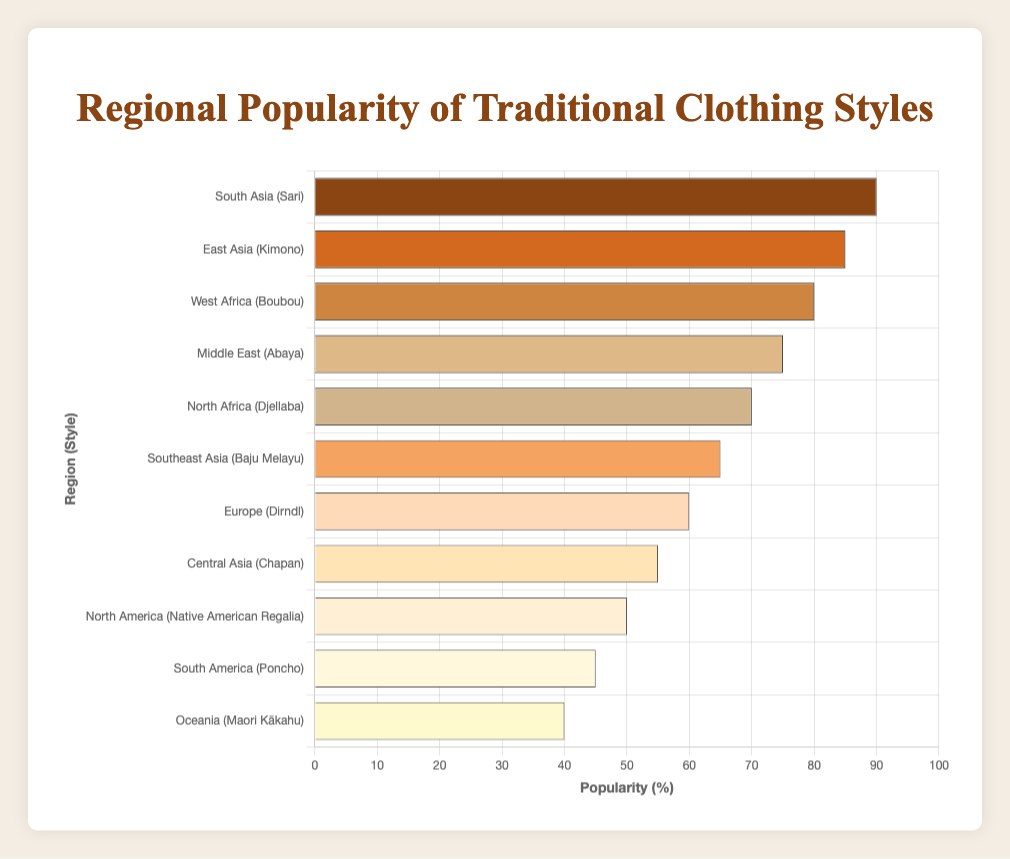Which region has the highest popularity for its traditional clothing style? The bar chart shows that South Asia has the highest popularity with the Sari style at 90%.
Answer: South Asia Which region has the lowest popularity for its traditional clothing style? The bar chart shows that Oceania has the lowest popularity with the Maori Kākahu style at 40%.
Answer: Oceania How much more popular is the Sari in South Asia compared to the Poncho in South America? The popularity of the Sari in South Asia is 90%, while the Poncho in South America is 45%. The difference is 90% - 45% = 45%.
Answer: 45% What is the average popularity of the traditional clothing styles in East Asia, South Asia, and West Africa? The popularity values for these styles are Kimono (85%), Sari (90%), and Boubou (80%). The average is calculated as (85 + 90 + 80) / 3 = 255 / 3 = 85%.
Answer: 85% Is the popularity of the Dirndl in Europe greater than that of the Chapan in Central Asia? The chart shows the popularity of the Dirndl in Europe is 60% and the Chapan in Central Asia is 55%. Since 60% > 55%, the Dirndl in Europe is more popular.
Answer: Yes What is the total popularity percentage for North Africa and the Middle East combined? The popularity of traditional clothing in North Africa is 70%, and in the Middle East is 75%. The total is 70% + 75% = 145%.
Answer: 145% Which two regions have the closest popularity values for their traditional clothing styles? The closest popularity values on the chart are East Asia (85% for Kimono) and West Africa (80% for Boubou), with a difference of 5%.
Answer: East Asia and West Africa Which color is associated with the Kimono style in East Asia on the bar chart? The color for Kimono in East Asia is shown as orange.
Answer: Orange Which traditional clothing style has a popularity percentage below 50%? The chart shows that North America (Native American Regalia), South America (Poncho), and Oceania (Maori Kākahu) have percentages below 50%.
Answer: Native American Regalia, Poncho, Maori Kākahu 